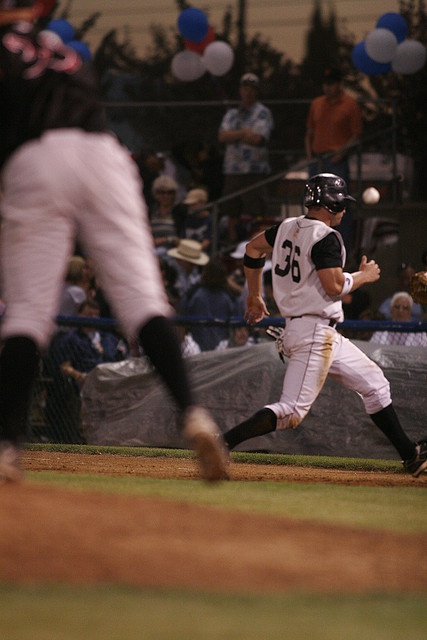Describe the objects in this image and their specific colors. I can see people in black, darkgray, gray, and brown tones, people in black, darkgray, gray, and brown tones, people in black and gray tones, people in maroon and black tones, and people in black, maroon, and gray tones in this image. 